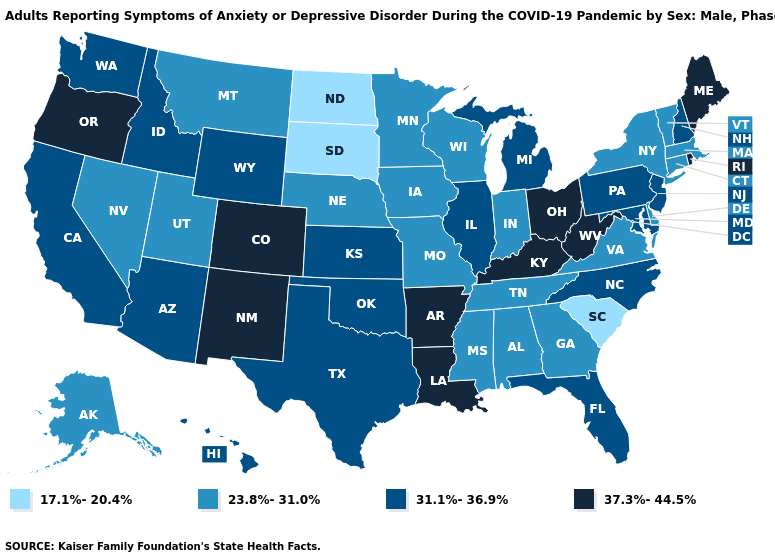What is the lowest value in the USA?
Concise answer only. 17.1%-20.4%. What is the lowest value in states that border Kansas?
Concise answer only. 23.8%-31.0%. Does Rhode Island have the highest value in the USA?
Concise answer only. Yes. Which states have the lowest value in the USA?
Give a very brief answer. North Dakota, South Carolina, South Dakota. Among the states that border Massachusetts , does New Hampshire have the lowest value?
Give a very brief answer. No. Among the states that border New York , does Connecticut have the lowest value?
Write a very short answer. Yes. Among the states that border Iowa , does Illinois have the highest value?
Write a very short answer. Yes. Among the states that border Pennsylvania , which have the lowest value?
Write a very short answer. Delaware, New York. Name the states that have a value in the range 23.8%-31.0%?
Give a very brief answer. Alabama, Alaska, Connecticut, Delaware, Georgia, Indiana, Iowa, Massachusetts, Minnesota, Mississippi, Missouri, Montana, Nebraska, Nevada, New York, Tennessee, Utah, Vermont, Virginia, Wisconsin. Among the states that border Wyoming , which have the lowest value?
Be succinct. South Dakota. What is the highest value in the USA?
Keep it brief. 37.3%-44.5%. Is the legend a continuous bar?
Be succinct. No. Does New Mexico have the lowest value in the West?
Answer briefly. No. What is the value of Maine?
Concise answer only. 37.3%-44.5%. 